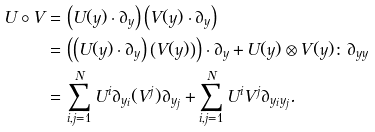Convert formula to latex. <formula><loc_0><loc_0><loc_500><loc_500>U \circ V = & \, \left ( U ( y ) \cdot \partial _ { y } \right ) \left ( V ( y ) \cdot \partial _ { y } \right ) \\ = & \, \left ( \left ( U ( y ) \cdot \partial _ { y } \right ) \left ( V ( y ) \right ) \right ) \cdot \partial _ { y } + U ( y ) \otimes V ( y ) \colon \partial _ { y y } \\ = & \, \sum _ { i , j = 1 } ^ { N } U ^ { i } \partial _ { y _ { i } } ( V ^ { j } ) \partial _ { y _ { j } } + \sum _ { i , j = 1 } ^ { N } U ^ { i } V ^ { j } \partial _ { y _ { i } y _ { j } } .</formula> 